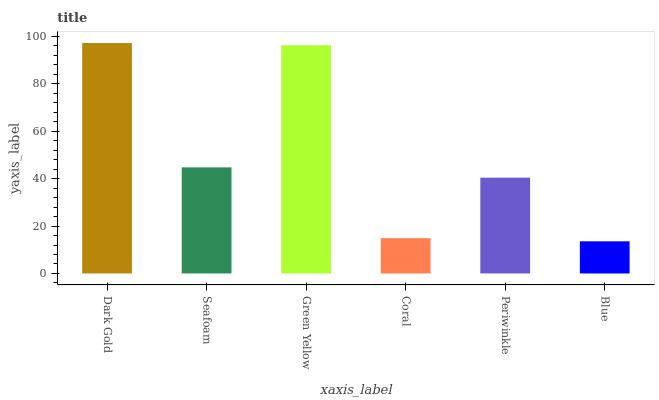Is Blue the minimum?
Answer yes or no. Yes. Is Dark Gold the maximum?
Answer yes or no. Yes. Is Seafoam the minimum?
Answer yes or no. No. Is Seafoam the maximum?
Answer yes or no. No. Is Dark Gold greater than Seafoam?
Answer yes or no. Yes. Is Seafoam less than Dark Gold?
Answer yes or no. Yes. Is Seafoam greater than Dark Gold?
Answer yes or no. No. Is Dark Gold less than Seafoam?
Answer yes or no. No. Is Seafoam the high median?
Answer yes or no. Yes. Is Periwinkle the low median?
Answer yes or no. Yes. Is Green Yellow the high median?
Answer yes or no. No. Is Blue the low median?
Answer yes or no. No. 